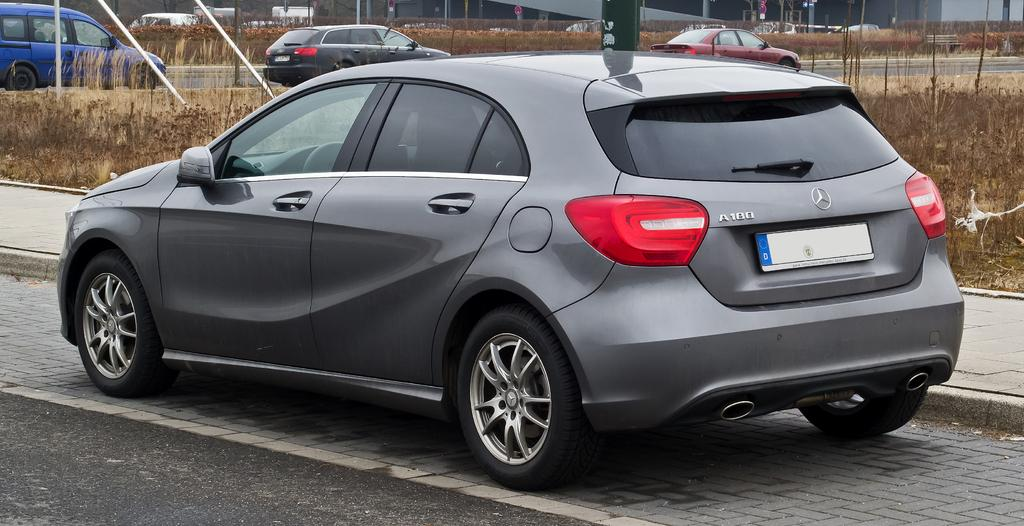What types of vehicles can be seen on the road in the image? There are vehicles on the road in the image. What type of vegetation is present in the image? There are plants and grass in the image. What objects can be seen in the image that are not related to the vehicles or vegetation? There are boards and poles in the image. How many beds are visible in the image? There are no beds present in the image. What type of payment is required to use the poles in the image? There is no indication in the image that any payment is required for the poles, as they are simply objects in the scene. 